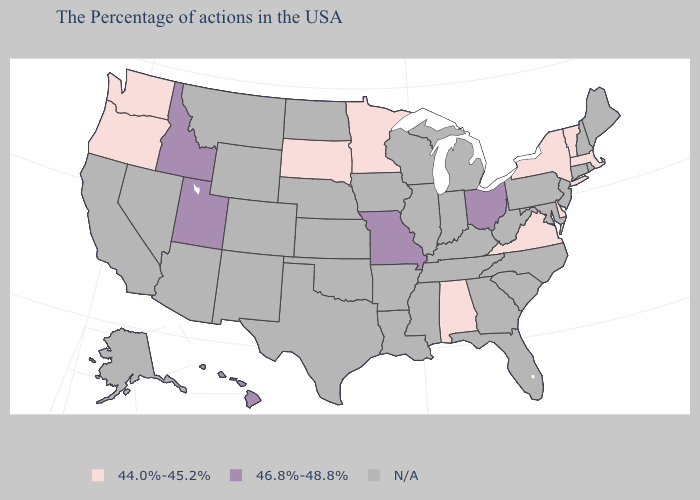Name the states that have a value in the range N/A?
Be succinct. Maine, Rhode Island, New Hampshire, Connecticut, New Jersey, Maryland, Pennsylvania, North Carolina, South Carolina, West Virginia, Florida, Georgia, Michigan, Kentucky, Indiana, Tennessee, Wisconsin, Illinois, Mississippi, Louisiana, Arkansas, Iowa, Kansas, Nebraska, Oklahoma, Texas, North Dakota, Wyoming, Colorado, New Mexico, Montana, Arizona, Nevada, California, Alaska. What is the value of Hawaii?
Answer briefly. 46.8%-48.8%. What is the highest value in the USA?
Keep it brief. 46.8%-48.8%. What is the value of New York?
Write a very short answer. 44.0%-45.2%. Name the states that have a value in the range 44.0%-45.2%?
Answer briefly. Massachusetts, Vermont, New York, Delaware, Virginia, Alabama, Minnesota, South Dakota, Washington, Oregon. Among the states that border Colorado , which have the highest value?
Concise answer only. Utah. Does the first symbol in the legend represent the smallest category?
Keep it brief. Yes. What is the value of Delaware?
Short answer required. 44.0%-45.2%. Does Hawaii have the highest value in the USA?
Keep it brief. Yes. What is the value of Virginia?
Give a very brief answer. 44.0%-45.2%. What is the highest value in the South ?
Concise answer only. 44.0%-45.2%. What is the highest value in the MidWest ?
Answer briefly. 46.8%-48.8%. 